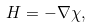<formula> <loc_0><loc_0><loc_500><loc_500>H = - \nabla \chi ,</formula> 